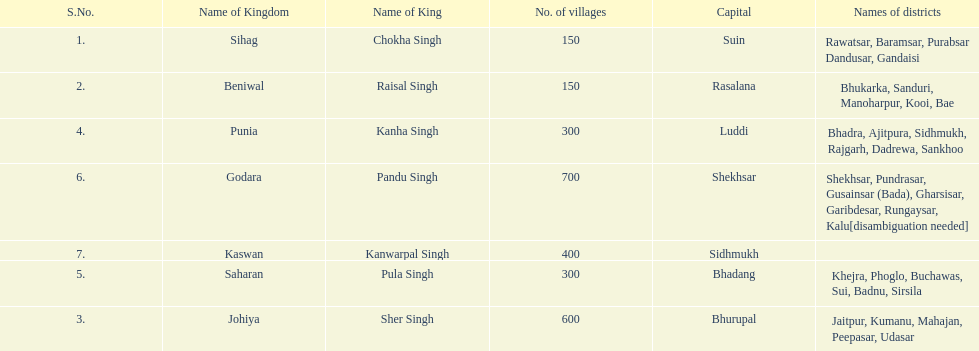Which kingdom has the most villages? Godara. Could you help me parse every detail presented in this table? {'header': ['S.No.', 'Name of Kingdom', 'Name of King', 'No. of villages', 'Capital', 'Names of districts'], 'rows': [['1.', 'Sihag', 'Chokha Singh', '150', 'Suin', 'Rawatsar, Baramsar, Purabsar Dandusar, Gandaisi'], ['2.', 'Beniwal', 'Raisal Singh', '150', 'Rasalana', 'Bhukarka, Sanduri, Manoharpur, Kooi, Bae'], ['4.', 'Punia', 'Kanha Singh', '300', 'Luddi', 'Bhadra, Ajitpura, Sidhmukh, Rajgarh, Dadrewa, Sankhoo'], ['6.', 'Godara', 'Pandu Singh', '700', 'Shekhsar', 'Shekhsar, Pundrasar, Gusainsar (Bada), Gharsisar, Garibdesar, Rungaysar, Kalu[disambiguation needed]'], ['7.', 'Kaswan', 'Kanwarpal Singh', '400', 'Sidhmukh', ''], ['5.', 'Saharan', 'Pula Singh', '300', 'Bhadang', 'Khejra, Phoglo, Buchawas, Sui, Badnu, Sirsila'], ['3.', 'Johiya', 'Sher Singh', '600', 'Bhurupal', 'Jaitpur, Kumanu, Mahajan, Peepasar, Udasar']]} 